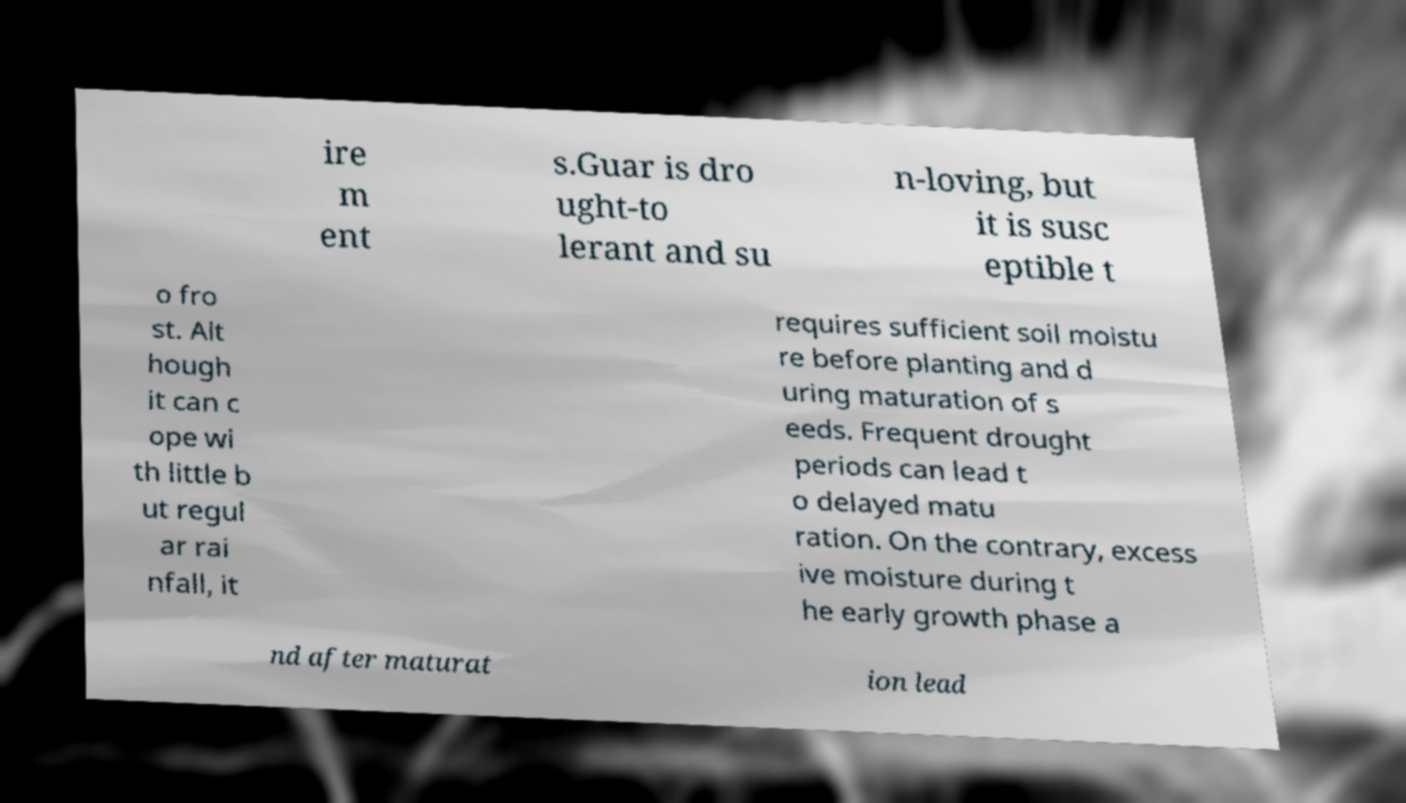Could you extract and type out the text from this image? ire m ent s.Guar is dro ught-to lerant and su n-loving, but it is susc eptible t o fro st. Alt hough it can c ope wi th little b ut regul ar rai nfall, it requires sufficient soil moistu re before planting and d uring maturation of s eeds. Frequent drought periods can lead t o delayed matu ration. On the contrary, excess ive moisture during t he early growth phase a nd after maturat ion lead 